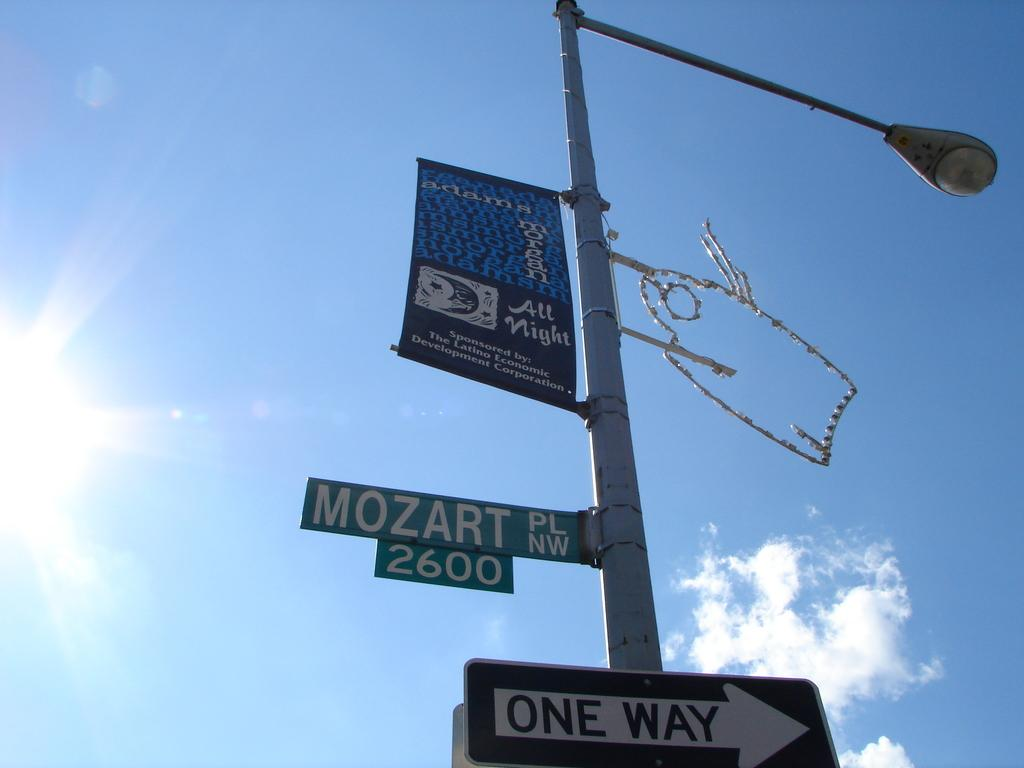<image>
Relay a brief, clear account of the picture shown. Decorated lamp post located at 2600 Mozart PL NW. 